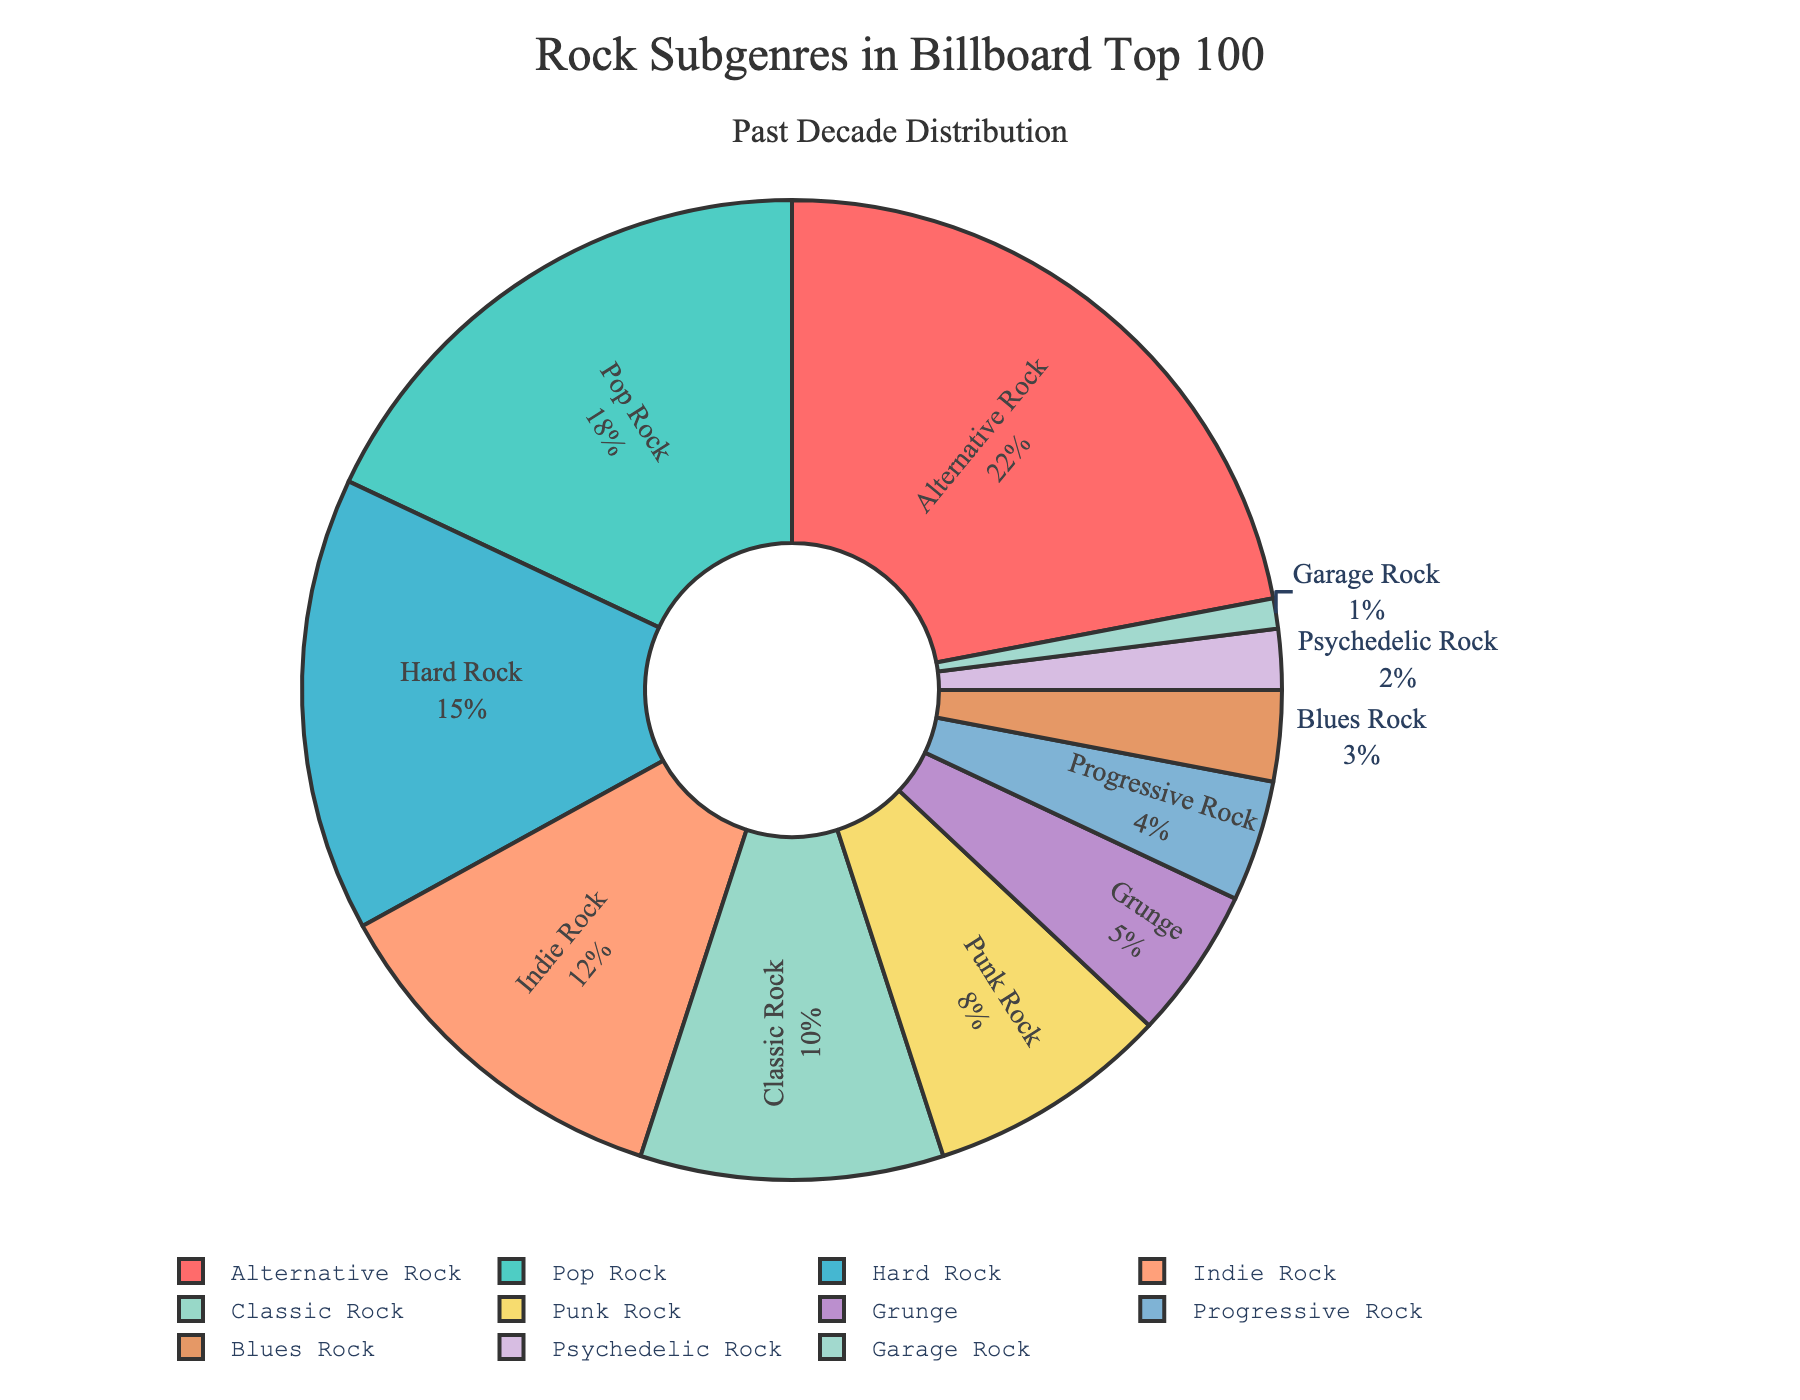Which subgenre has the highest percentage in the Billboard Top 100 over the past decade? By observing the pie chart, you can see the segment labeled "Alternative Rock" has the largest portion.
Answer: Alternative Rock What is the combined percentage of Pop Rock and Hard Rock in the Billboard Top 100? According to the pie chart, Pop Rock is 18% and Hard Rock is 15%. Adding these together, 18% + 15% = 33%.
Answer: 33% Is the percentage for Indie Rock greater, less, or equal to the percentage for Classic Rock? By comparing the size of the segments in the pie chart, Indie Rock (12%) is greater than Classic Rock (10%).
Answer: Greater How much more does Alternative Rock account for compared to Grunge? Alternative Rock comprises 22% and Grunge makes up 5%. The difference between them is 22% - 5% = 17%.
Answer: 17% Which subgenres together make up more than 50% of the Billboard Top 100? Summing up the percentages in order from largest to smallest, we see Alternative Rock (22%) + Pop Rock (18%) = 40%, then adding Hard Rock (15%) reaches 55%, confirming these three subgenres together exceed 50%.
Answer: Alternative Rock, Pop Rock, Hard Rock What percentage of the Billboard Top 100 do the least represented three subgenres account for? The pie chart shows the least represented subgenres are Garage Rock (1%), Psychedelic Rock (2%), and Blues Rock (3%). Adding these, 1% + 2% + 3% = 6%.
Answer: 6% What color is used to represent Punk Rock in the pie chart? By examining the chart, the segment labeled "Punk Rock" is colored in a distinctive light yellow hue.
Answer: Light Yellow How does the percentage of Progressive Rock compare to Punk Rock? The pie chart shows that Progressive Rock has 4% while Punk Rock has 8%. Therefore, Progressive Rock is half of Punk Rock.
Answer: Half What is the difference between the combined percentage of the top three subgenres and the bottom three subgenres? The top three subgenres, Alternative Rock (22%), Pop Rock (18%), and Hard Rock (15%) total to 55%. The bottom three subgenres, Garage Rock (1%), Psychedelic Rock (2%), and Blues Rock (3%) total to 6%. The difference is 55% - 6% = 49%.
Answer: 49% Which subgenre has a lower percentage than Classic Rock but higher than Progressive Rock? The chart indicates Indie Rock with 12%, fitting the criteria of being less than Classic Rock (10%) but greater than Progressive Rock (4%).
Answer: Indie Rock 